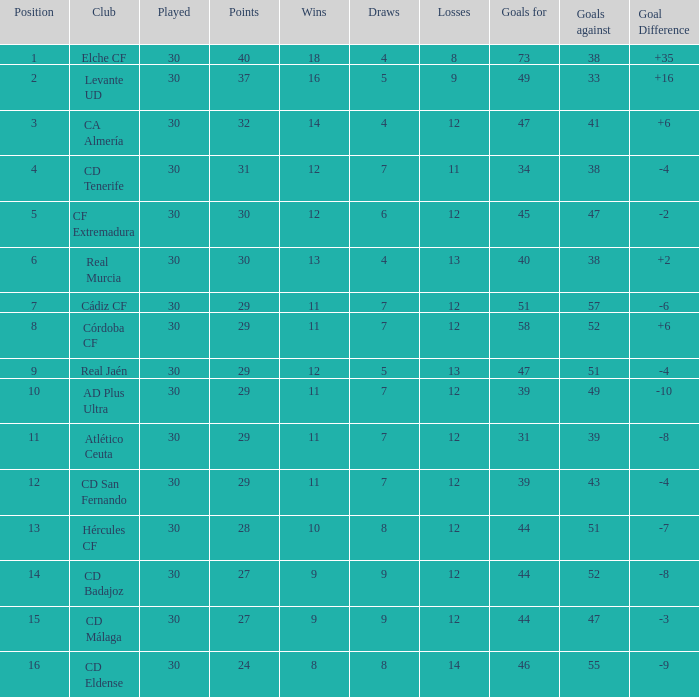What is the sum of the goals with less than 30 points, a position less than 10, and more than 57 goals against? None. 